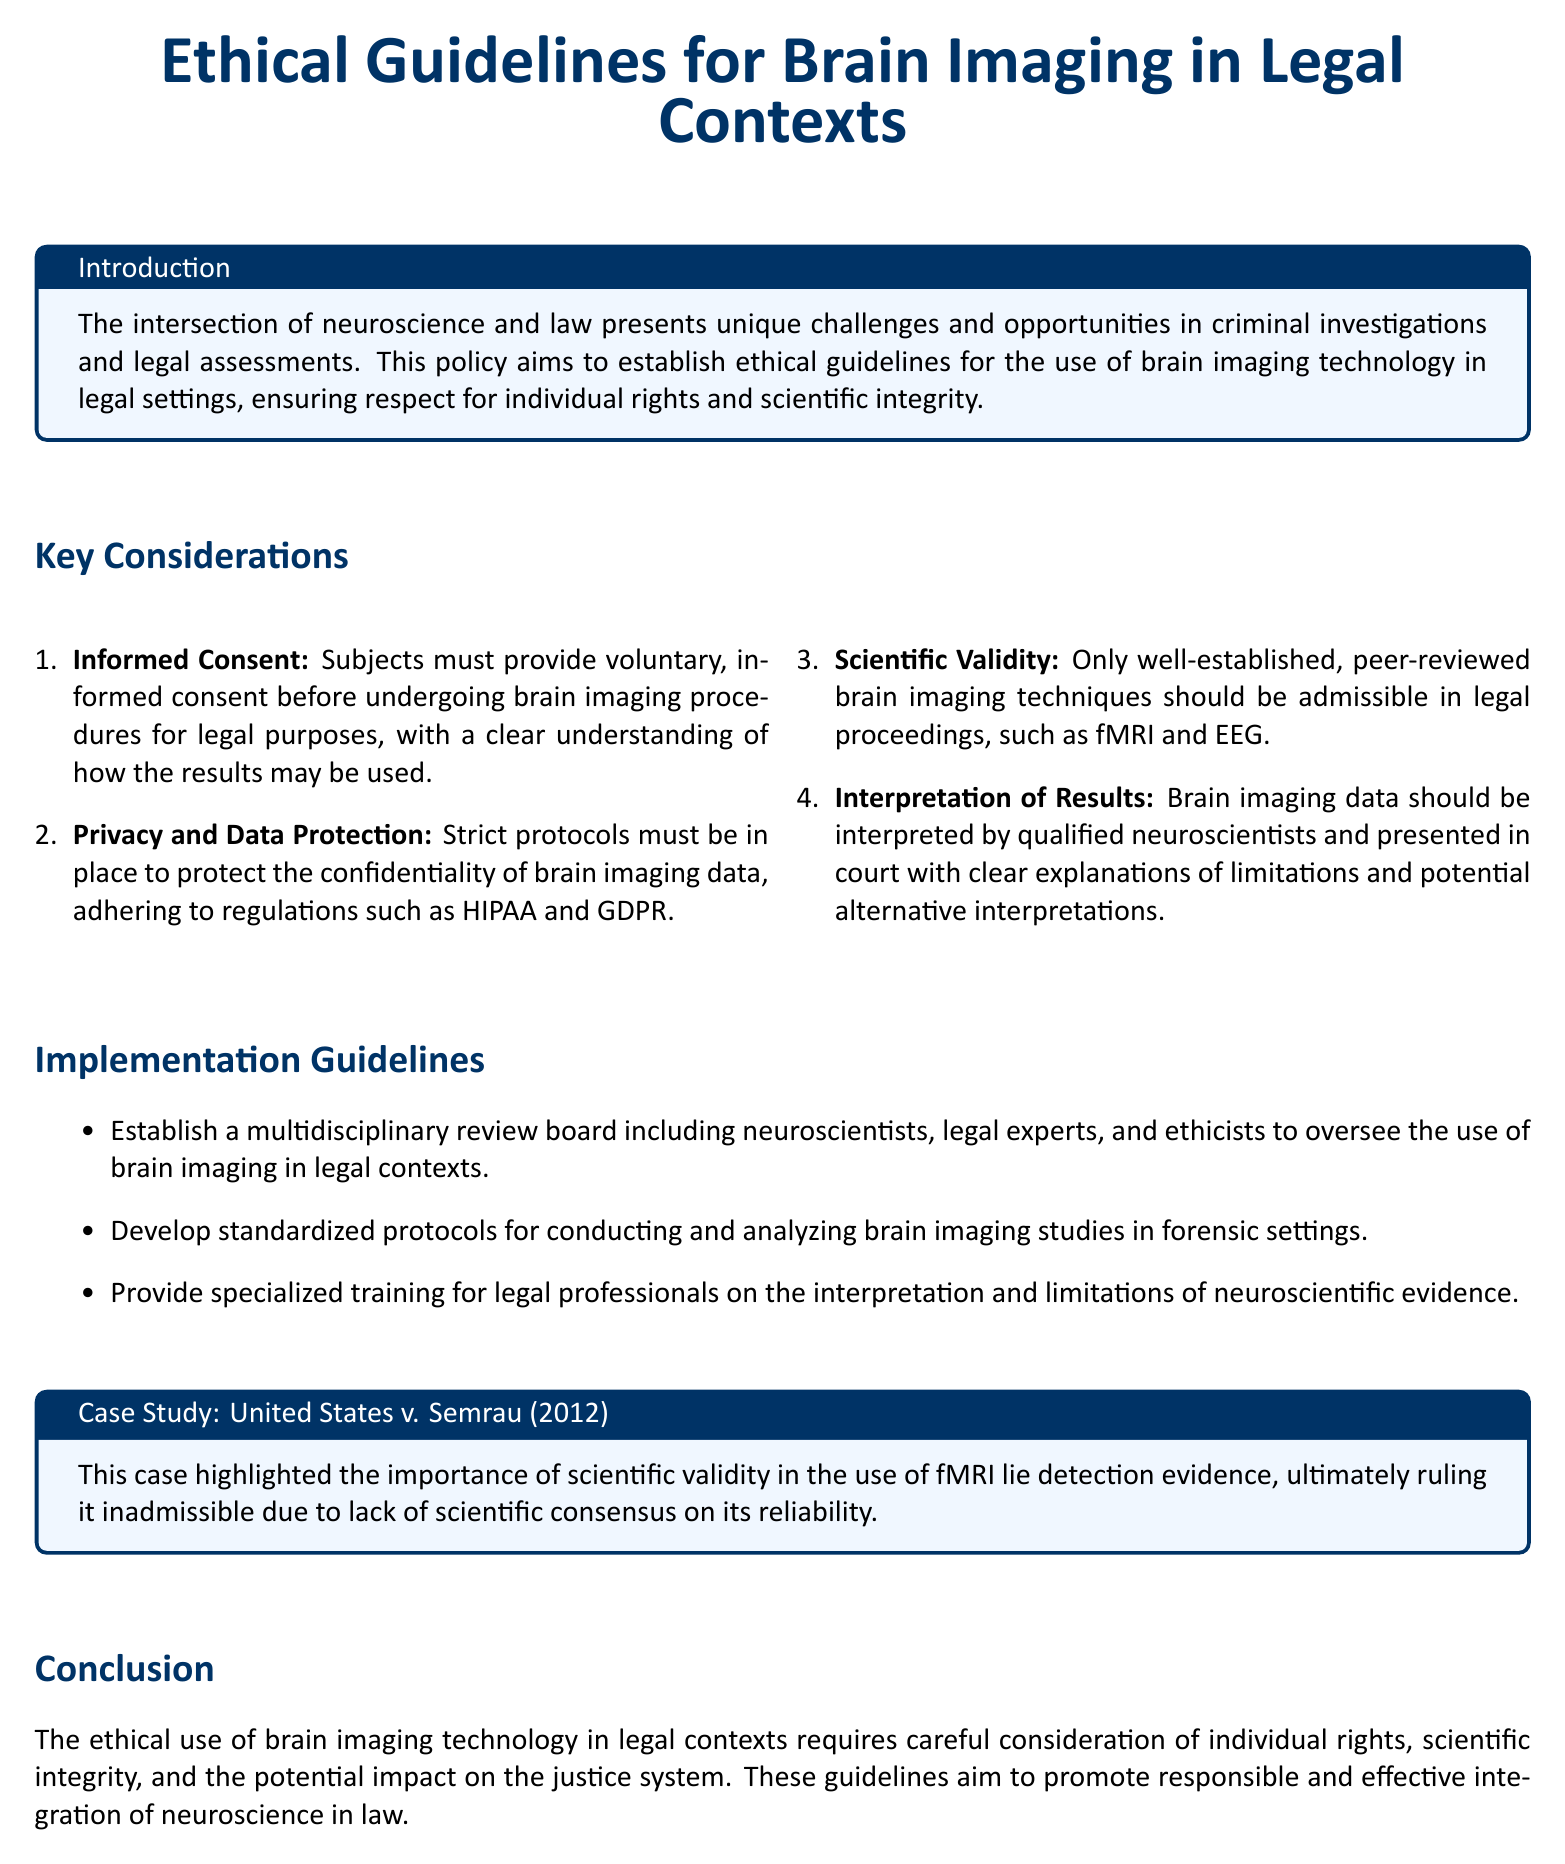What is the title of the document? The title is presented at the beginning of the document and outlines the main focus on ethical guidelines.
Answer: Ethical Guidelines for Brain Imaging in Legal Contexts What is the year of the case study mentioned? The case study is referenced in a specific format that includes the year it took place.
Answer: 2012 What technology is mentioned as an example of brain imaging? The document explicitly mentions types of brain imaging technology that are used for legal assessments.
Answer: fMRI and EEG What must subjects provide before undergoing brain imaging procedures? The introduction of informed consent is described, indicating what subjects must do.
Answer: Voluntary, informed consent Who should interpret the brain imaging data according to the guidelines? The guidelines specify who is qualified to interpret the data, emphasizing expertise.
Answer: Qualified neuroscientists What principle addresses the confidentiality of brain imaging data? A key aspect of ethical considerations focuses on privacy and regulatory compliance.
Answer: Privacy and Data Protection What is required from the multidisciplinary review board? The document emphasizes the need for various experts in the review board overseeing brain imaging use.
Answer: Include neuroscientists, legal experts, and ethicists Which case emphasized the importance of scientific validity? The case study provided is specifically noted for its implications regarding admissibility in court.
Answer: United States v. Semrau What is the overall goal of the ethical guidelines? The conclusion summarizes the purpose of the guidelines concerning the justice system.
Answer: Promote responsible and effective integration of neuroscience in law 